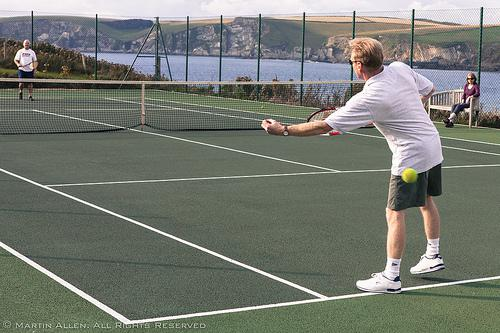Question: where was this taken?
Choices:
A. Squash court.
B. Wimbledon.
C. Tennis court.
D. Olympics.
Answer with the letter. Answer: C Question: how many people are in the photo?
Choices:
A. Three.
B. Two.
C. Four.
D. Five.
Answer with the letter. Answer: A Question: what is the woman doing?
Choices:
A. Eating dinner.
B. Sitting on a bench watching.
C. Walking down the street.
D. Talking on the telephone.
Answer with the letter. Answer: B Question: what color is the ball?
Choices:
A. Yellow.
B. Orange.
C. Red.
D. Blue.
Answer with the letter. Answer: A Question: what is in the man's hand?
Choices:
A. Football.
B. Hockey puck.
C. Tennis racket.
D. Baseball bat.
Answer with the letter. Answer: C Question: who is playing tennis?
Choices:
A. A man and a woman.
B. Two men.
C. Two women.
D. A boy and a man.
Answer with the letter. Answer: B 